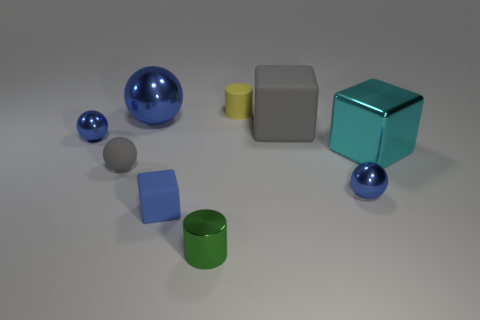Subtract all green blocks. How many blue spheres are left? 3 Subtract 1 balls. How many balls are left? 3 Add 1 blue objects. How many objects exist? 10 Subtract all cylinders. How many objects are left? 7 Subtract 2 blue balls. How many objects are left? 7 Subtract all tiny rubber things. Subtract all big yellow cylinders. How many objects are left? 6 Add 2 tiny blue shiny objects. How many tiny blue shiny objects are left? 4 Add 8 tiny yellow matte things. How many tiny yellow matte things exist? 9 